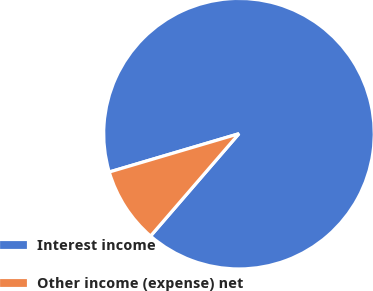Convert chart to OTSL. <chart><loc_0><loc_0><loc_500><loc_500><pie_chart><fcel>Interest income<fcel>Other income (expense) net<nl><fcel>90.91%<fcel>9.09%<nl></chart> 